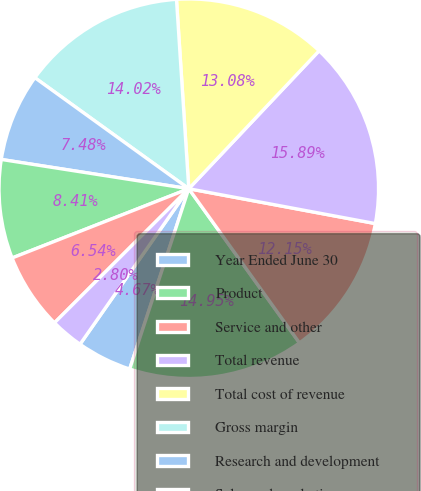Convert chart to OTSL. <chart><loc_0><loc_0><loc_500><loc_500><pie_chart><fcel>Year Ended June 30<fcel>Product<fcel>Service and other<fcel>Total revenue<fcel>Total cost of revenue<fcel>Gross margin<fcel>Research and development<fcel>Sales and marketing<fcel>General and administrative<fcel>Impairment and restructuring<nl><fcel>4.67%<fcel>14.95%<fcel>12.15%<fcel>15.89%<fcel>13.08%<fcel>14.02%<fcel>7.48%<fcel>8.41%<fcel>6.54%<fcel>2.8%<nl></chart> 